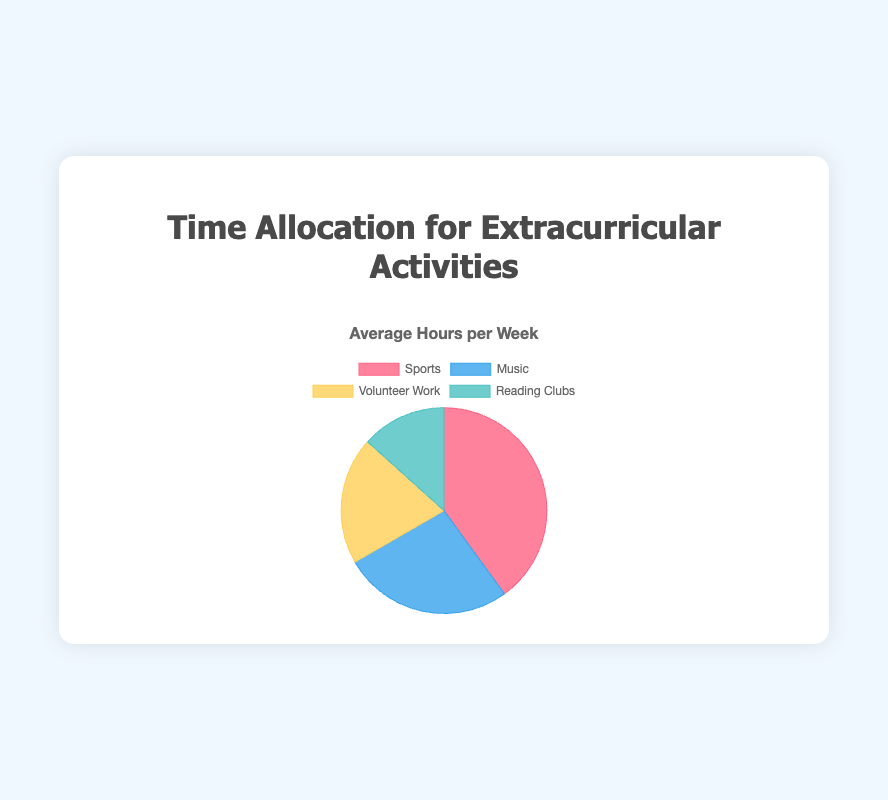What activity takes up the most time per week on average? The pie chart shows various extracurricular activities and their average hours per week. Sports has the largest section of the pie chart.
Answer: Sports How many more hours per week do people spend on Music compared to Reading Clubs? According to the chart, Music takes up 4 hours per week, while Reading Clubs take up 2 hours per week. So, 4 - 2 = 2 hours more are spent on Music.
Answer: 2 hours What is the total average time spent on Volunteer Work and Reading Clubs? The chart provides 3 hours per week for Volunteer Work and 2 hours per week for Reading Clubs. Summing these gives 3 + 2 = 5 hours.
Answer: 5 hours Which activity has the least average hours per week? By looking at the pie chart, the smallest section corresponds to Reading Clubs.
Answer: Reading Clubs Is the time spent on Sports more than twice the time spent on Volunteer Work? Sports takes up 6 hours per week, and Volunteer Work takes up 3 hours per week. Since 6 > 2 * 3, Sports is indeed more than twice Volunteer Work.
Answer: Yes What are the average hours per week spent on the three activities that do not include Sports? The activities excluding Sports are Music (4 hours), Volunteer Work (3 hours), and Reading Clubs (2 hours). Summing these gives 4 + 3 + 2 = 9 hours.
Answer: 9 hours What is the ratio of time spent on Sports to time spent on Music? Sports takes up 6 hours and Music takes up 4 hours per week. Therefore, the ratio is 6:4, which simplifies to 3:2.
Answer: 3:2 Which activities together account for the same number of hours as Sports? Sports takes 6 hours per week. The combination of Music (4 hours) and Volunteer Work (3 hours) sums to 4 + 3 = 7 hours, but Music and Reading Clubs total 4 + 2 = 6 hours, which matches Sports.
Answer: Music and Reading Clubs How many times greater is the average time spent on Sports than on Reading Clubs? Sports accounts for 6 hours per week, and Reading Clubs for 2 hours. Dividing these gives 6 / 2 = 3 times greater.
Answer: 3 times By how much does time spent on Music exceed the time spent on Volunteer Work and Reading Clubs combined? Music takes up 4 hours per week. Volunteer Work and Reading Clubs combined are 3 + 2 = 5 hours. Since 5 > 4, Music doesn’t exceed the combined time of Volunteer Work and Reading Clubs; instead, the combined time exceeds Music by 5 - 4 = 1 hour.
Answer: Music does not exceed 